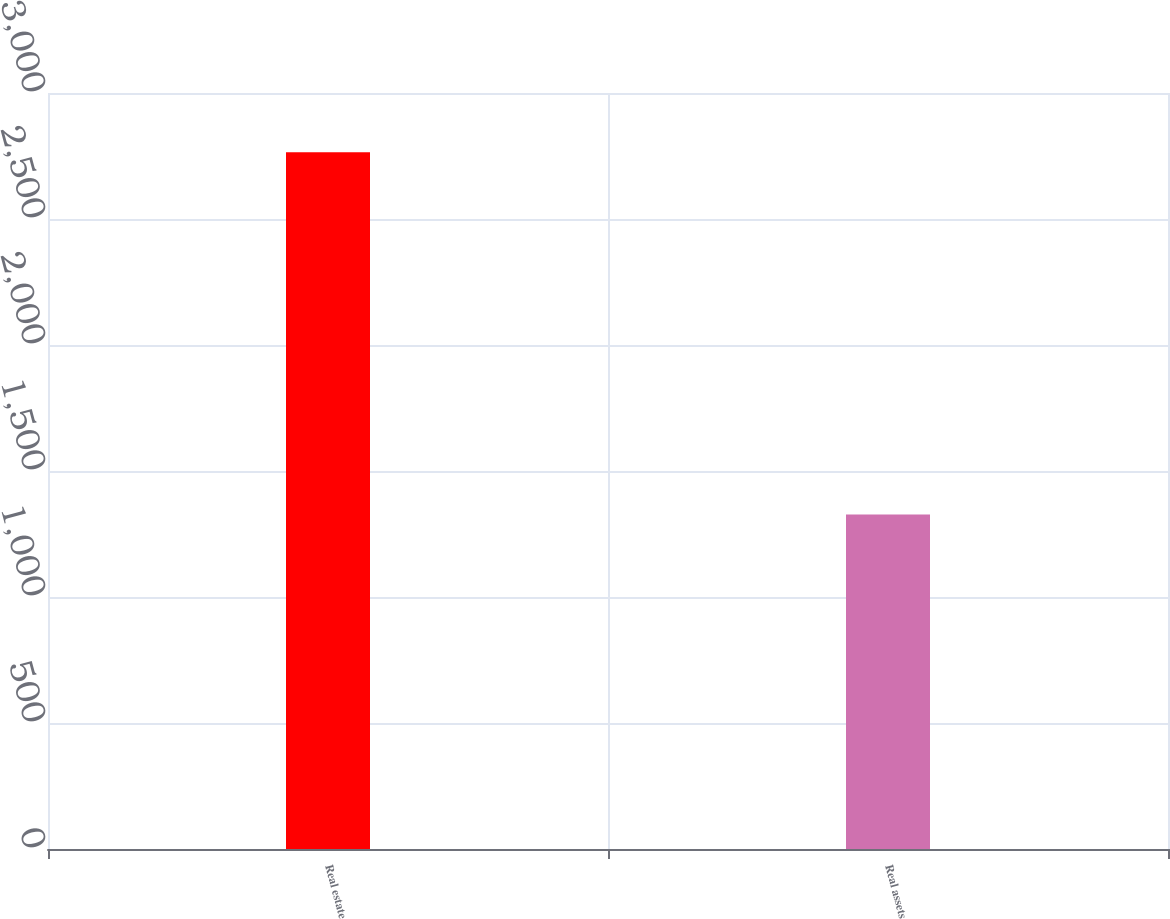Convert chart. <chart><loc_0><loc_0><loc_500><loc_500><bar_chart><fcel>Real estate<fcel>Real assets<nl><fcel>2765<fcel>1327<nl></chart> 